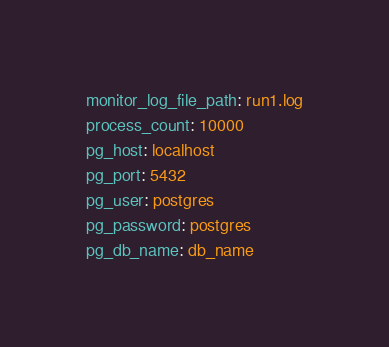Convert code to text. <code><loc_0><loc_0><loc_500><loc_500><_YAML_>monitor_log_file_path: run1.log
process_count: 10000
pg_host: localhost
pg_port: 5432
pg_user: postgres
pg_password: postgres
pg_db_name: db_name
</code> 